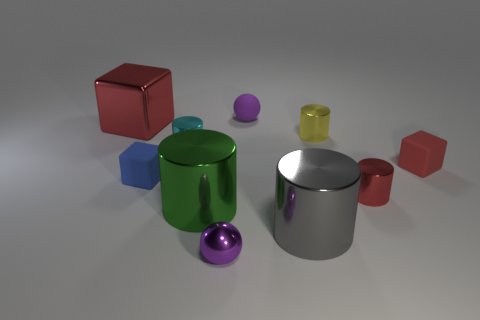Subtract 1 cylinders. How many cylinders are left? 4 Subtract all cyan cylinders. How many cylinders are left? 4 Subtract all small red metallic cylinders. How many cylinders are left? 4 Subtract all green cylinders. Subtract all blue balls. How many cylinders are left? 4 Subtract all cubes. How many objects are left? 7 Add 5 green metallic spheres. How many green metallic spheres exist? 5 Subtract 1 blue cubes. How many objects are left? 9 Subtract all large cyan matte cubes. Subtract all blue rubber things. How many objects are left? 9 Add 2 green shiny cylinders. How many green shiny cylinders are left? 3 